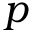Convert formula to latex. <formula><loc_0><loc_0><loc_500><loc_500>p</formula> 